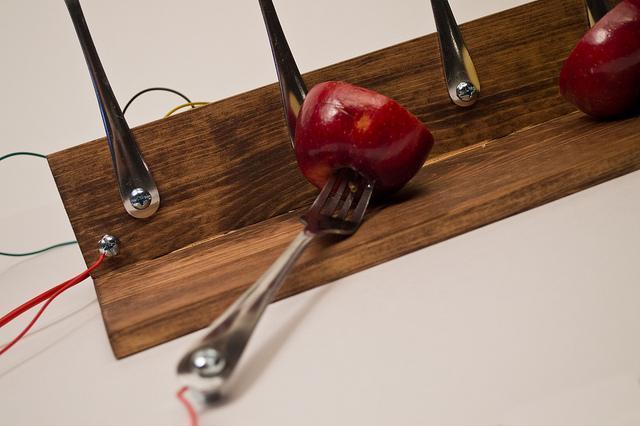How many apples are there?
Give a very brief answer. 2. 